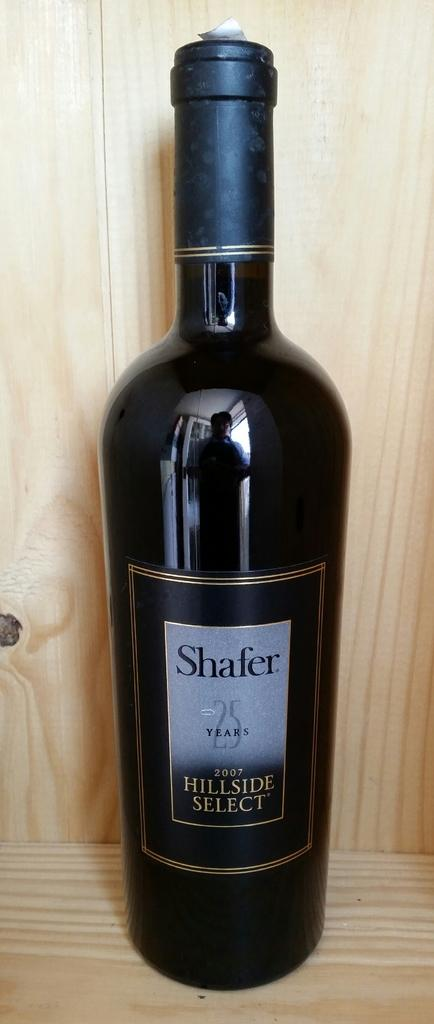<image>
Give a short and clear explanation of the subsequent image. A black bottle of Shafer Hillside select wine sitting in a wooden cabinet. 